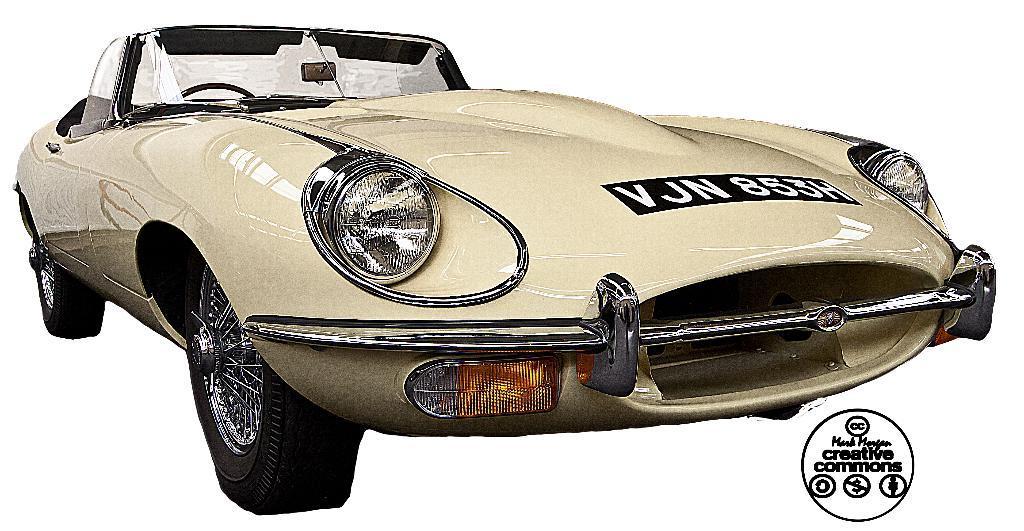Could you give a brief overview of what you see in this image? In this image we can see a car with group of headlights, a bumper ,mirrors and set of indicators. 